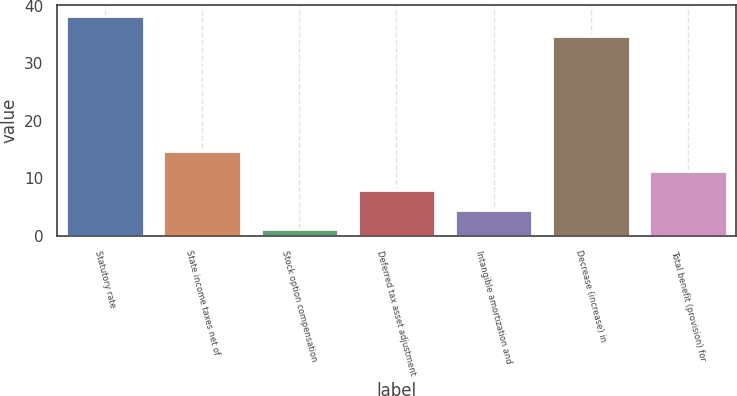Convert chart to OTSL. <chart><loc_0><loc_0><loc_500><loc_500><bar_chart><fcel>Statutory rate<fcel>State income taxes net of<fcel>Stock option compensation<fcel>Deferred tax asset adjustment<fcel>Intangible amortization and<fcel>Decrease (increase) in<fcel>Total benefit (provision) for<nl><fcel>38.18<fcel>14.72<fcel>1.2<fcel>7.96<fcel>4.58<fcel>34.8<fcel>11.34<nl></chart> 